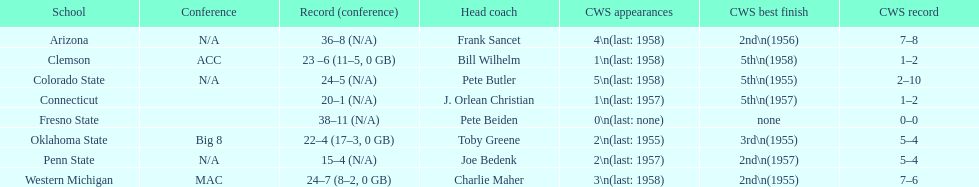Oklahoma state and penn state both have how many cws appearances? 2. Could you help me parse every detail presented in this table? {'header': ['School', 'Conference', 'Record (conference)', 'Head coach', 'CWS appearances', 'CWS best finish', 'CWS record'], 'rows': [['Arizona', 'N/A', '36–8 (N/A)', 'Frank Sancet', '4\\n(last: 1958)', '2nd\\n(1956)', '7–8'], ['Clemson', 'ACC', '23 –6 (11–5, 0 GB)', 'Bill Wilhelm', '1\\n(last: 1958)', '5th\\n(1958)', '1–2'], ['Colorado State', 'N/A', '24–5 (N/A)', 'Pete Butler', '5\\n(last: 1958)', '5th\\n(1955)', '2–10'], ['Connecticut', '', '20–1 (N/A)', 'J. Orlean Christian', '1\\n(last: 1957)', '5th\\n(1957)', '1–2'], ['Fresno State', '', '38–11 (N/A)', 'Pete Beiden', '0\\n(last: none)', 'none', '0–0'], ['Oklahoma State', 'Big 8', '22–4 (17–3, 0 GB)', 'Toby Greene', '2\\n(last: 1955)', '3rd\\n(1955)', '5–4'], ['Penn State', 'N/A', '15–4 (N/A)', 'Joe Bedenk', '2\\n(last: 1957)', '2nd\\n(1957)', '5–4'], ['Western Michigan', 'MAC', '24–7 (8–2, 0 GB)', 'Charlie Maher', '3\\n(last: 1958)', '2nd\\n(1955)', '7–6']]} 